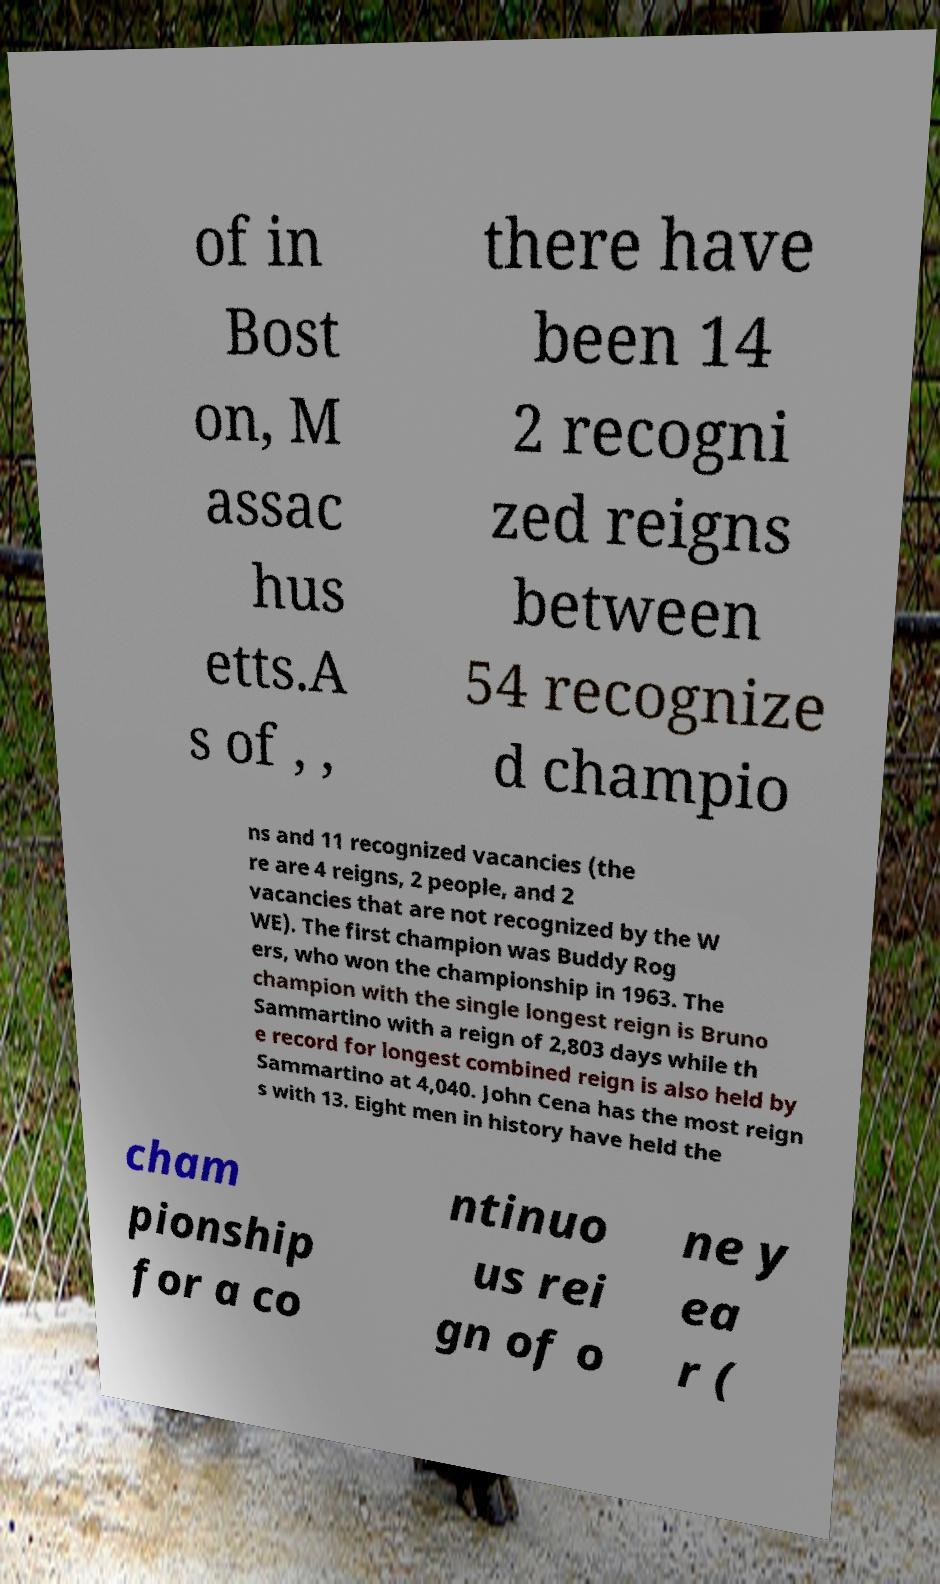Can you accurately transcribe the text from the provided image for me? of in Bost on, M assac hus etts.A s of , , there have been 14 2 recogni zed reigns between 54 recognize d champio ns and 11 recognized vacancies (the re are 4 reigns, 2 people, and 2 vacancies that are not recognized by the W WE). The first champion was Buddy Rog ers, who won the championship in 1963. The champion with the single longest reign is Bruno Sammartino with a reign of 2,803 days while th e record for longest combined reign is also held by Sammartino at 4,040. John Cena has the most reign s with 13. Eight men in history have held the cham pionship for a co ntinuo us rei gn of o ne y ea r ( 